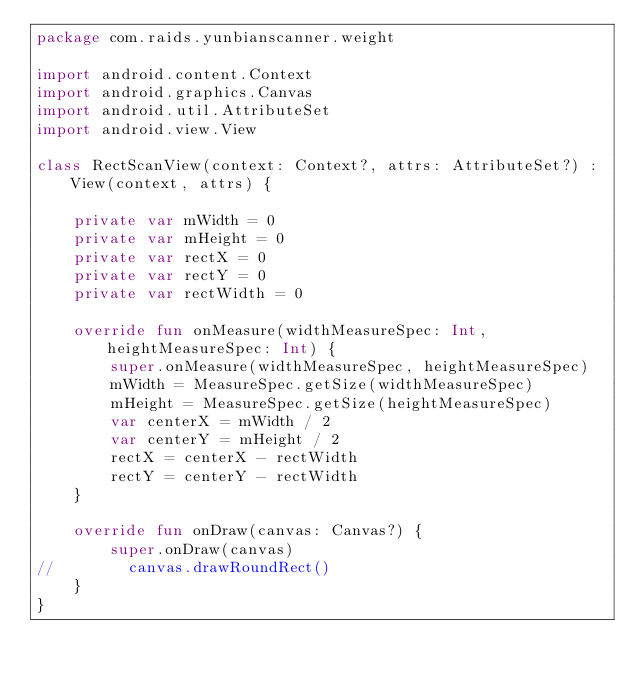<code> <loc_0><loc_0><loc_500><loc_500><_Kotlin_>package com.raids.yunbianscanner.weight

import android.content.Context
import android.graphics.Canvas
import android.util.AttributeSet
import android.view.View

class RectScanView(context: Context?, attrs: AttributeSet?) : View(context, attrs) {

    private var mWidth = 0
    private var mHeight = 0
    private var rectX = 0
    private var rectY = 0
    private var rectWidth = 0

    override fun onMeasure(widthMeasureSpec: Int, heightMeasureSpec: Int) {
        super.onMeasure(widthMeasureSpec, heightMeasureSpec)
        mWidth = MeasureSpec.getSize(widthMeasureSpec)
        mHeight = MeasureSpec.getSize(heightMeasureSpec)
        var centerX = mWidth / 2
        var centerY = mHeight / 2
        rectX = centerX - rectWidth
        rectY = centerY - rectWidth
    }

    override fun onDraw(canvas: Canvas?) {
        super.onDraw(canvas)
//        canvas.drawRoundRect()
    }
}</code> 